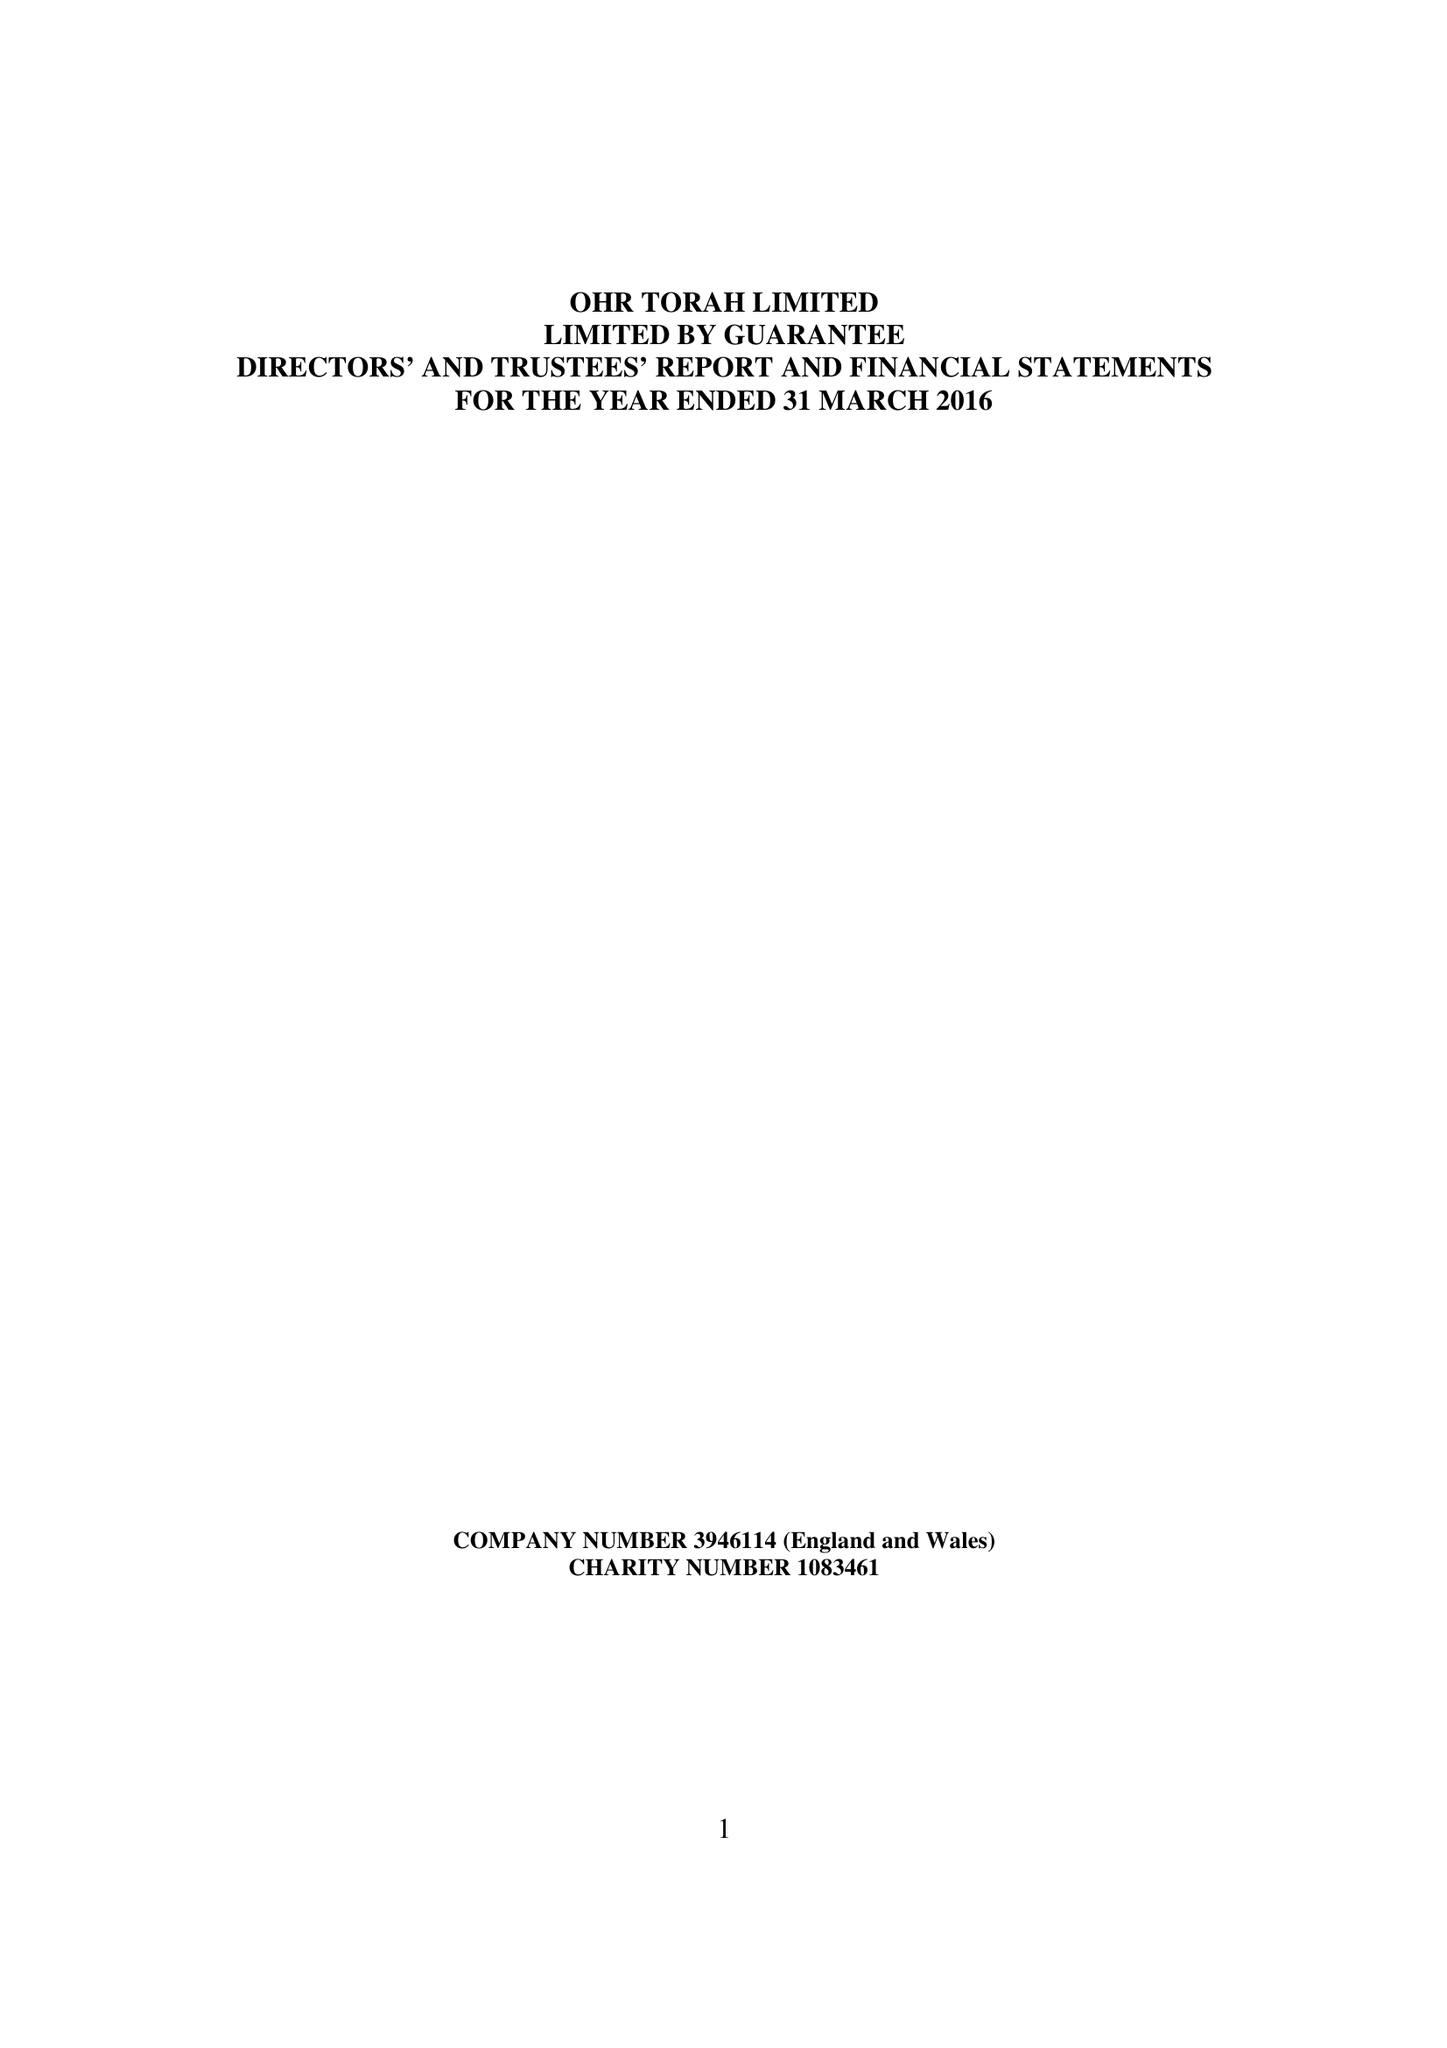What is the value for the address__post_town?
Answer the question using a single word or phrase. MANCHESTER 